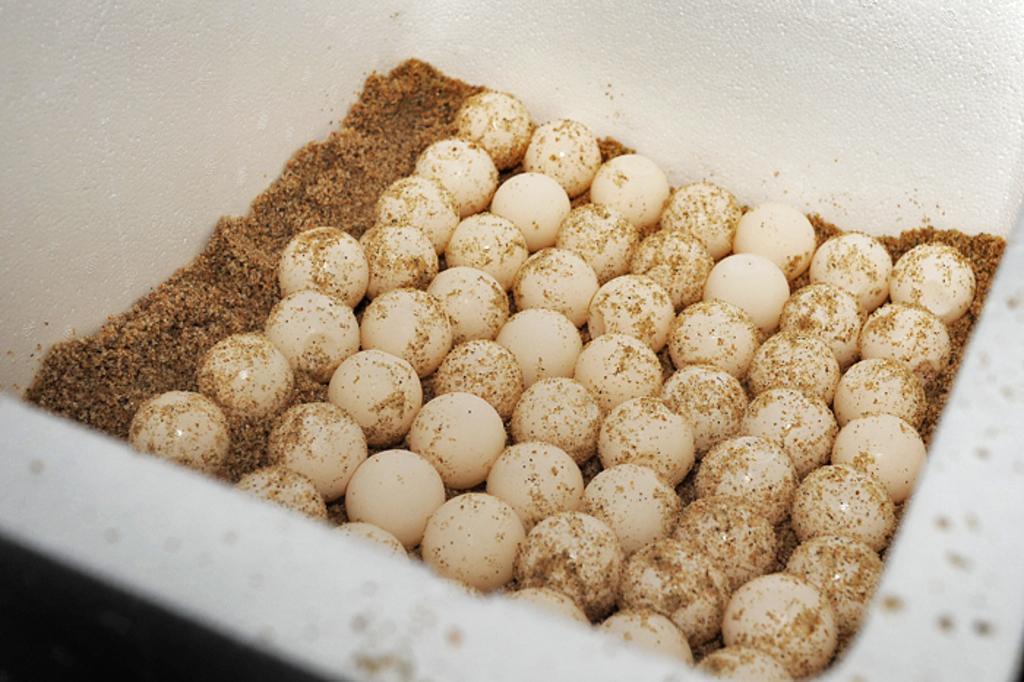Please provide a concise description of this image. There is a white box. In that there are eggs and brown color powdered thing. 